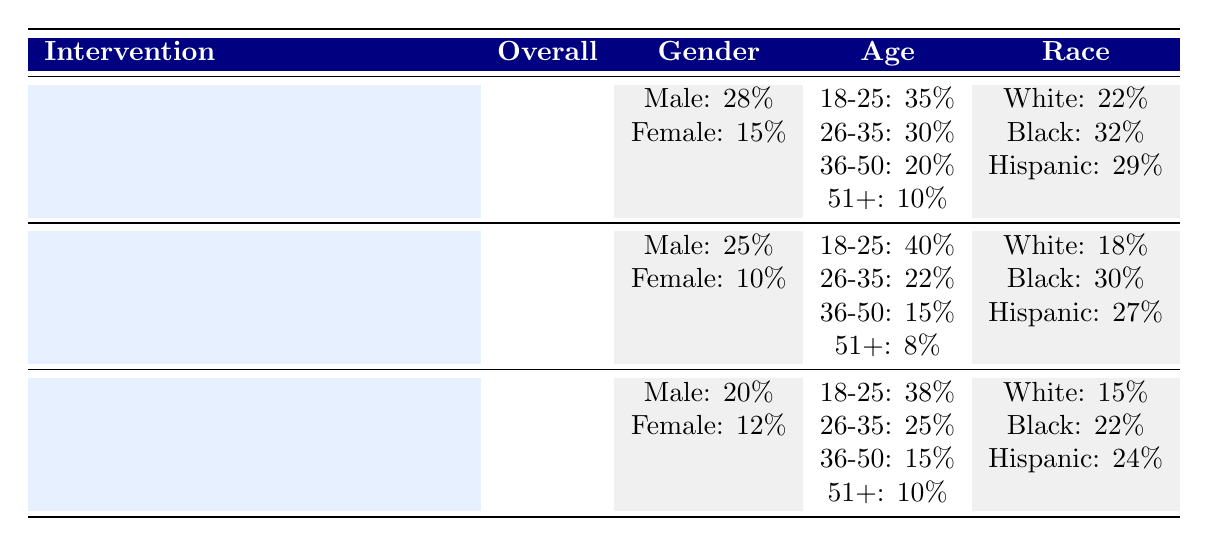What is the overall recidivism rate? The table states that the overall recidivism rate is 30%. This information can be found in the "Overall" section of the table.
Answer: 30% Which intervention has the highest effectiveness rate? According to the table, Cognitive Behavioral Therapy has the highest effectiveness rate at 25%, compared to Substance Abuse Programs at 20% and Job Training Programs at 18%.
Answer: Cognitive Behavioral Therapy What is the recidivism rate for females under Cognitive Behavioral Therapy? The table shows that female recidivism under Cognitive Behavioral Therapy is 15%, which is specified in the demographics section concerning gender.
Answer: 15% What is the average effectiveness rate of the three interventions? The effectiveness rates of the three interventions are 25% (Cognitive Behavioral Therapy), 20% (Substance Abuse Programs), and 18% (Job Training Programs). Adding these gives a total of 63%, and dividing by 3 results in an average effectiveness of 21%.
Answer: 21% Is the recidivism rate for Black individuals higher under Substance Abuse Programs compared to Job Training Programs? The recidivism rate for Black individuals is 30% under Substance Abuse Programs and 22% under Job Training Programs. Since 30% is greater than 22%, the answer is yes.
Answer: Yes What is the difference in recidivism rates for males aged 18-25 between Cognitive Behavioral Therapy and Substance Abuse Programs? The recidivism rate for males aged 18-25 is 28% under Cognitive Behavioral Therapy and 25% under Substance Abuse Programs. The difference is 28% - 25% = 3%.
Answer: 3% Which age group has the lowest recidivism rate across all interventions? Analyzing the age demographics, the group aged 51+ has the lowest rates: 10% under Cognitive Behavioral Therapy, 8% under Substance Abuse Programs, and 10% under Job Training Programs. The lowest recidivism rate, therefore, is 8%.
Answer: 8% Are the recidivism rates for Hispanic individuals under Job Training Programs and Cognitive Behavioral Therapy the same? The table shows that Hispanic recidivism rates are 24% under Job Training Programs and 29% under Cognitive Behavioral Therapy. Since these values are different, the answer is no.
Answer: No 